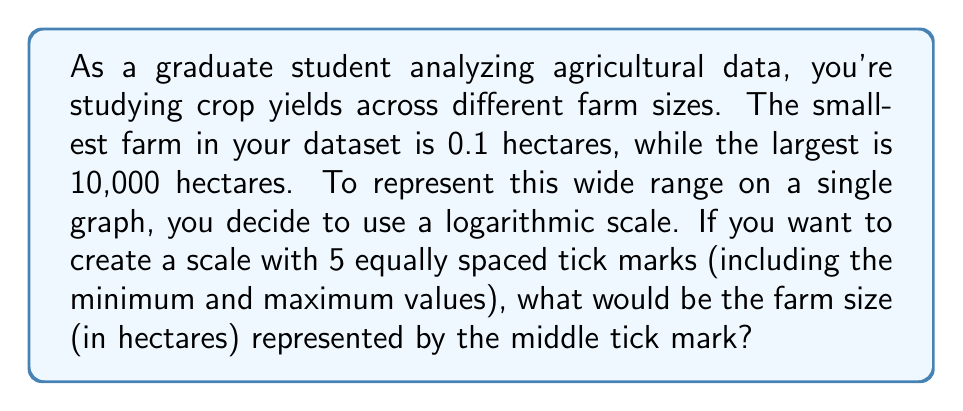Solve this math problem. To solve this problem, we need to use logarithmic scaling. Here's a step-by-step approach:

1) First, let's convert the farm sizes to logarithms. We'll use base 10 for simplicity:
   
   Smallest farm: $\log_{10}(0.1) = -1$
   Largest farm: $\log_{10}(10,000) = 4$

2) The logarithmic scale will range from -1 to 4, a total span of 5 log units.

3) With 5 tick marks, there will be 4 equal intervals. To find the size of each interval:

   $\text{Interval size} = \frac{4 - (-1)}{4} = \frac{5}{4} = 1.25$ log units

4) The middle tick mark will be 2 intervals above the minimum:

   $-1 + (2 * 1.25) = 1.5$

5) So, the middle tick mark corresponds to $\log_{10}(x) = 1.5$, where $x$ is the farm size we're looking for.

6) To find $x$, we need to reverse the logarithm:

   $x = 10^{1.5}$

7) Calculate this value:

   $10^{1.5} = 10^1 * 10^{0.5} = 10 * \sqrt{10} \approx 31.62277660168379$
Answer: The middle tick mark represents a farm size of approximately 31.62 hectares. 